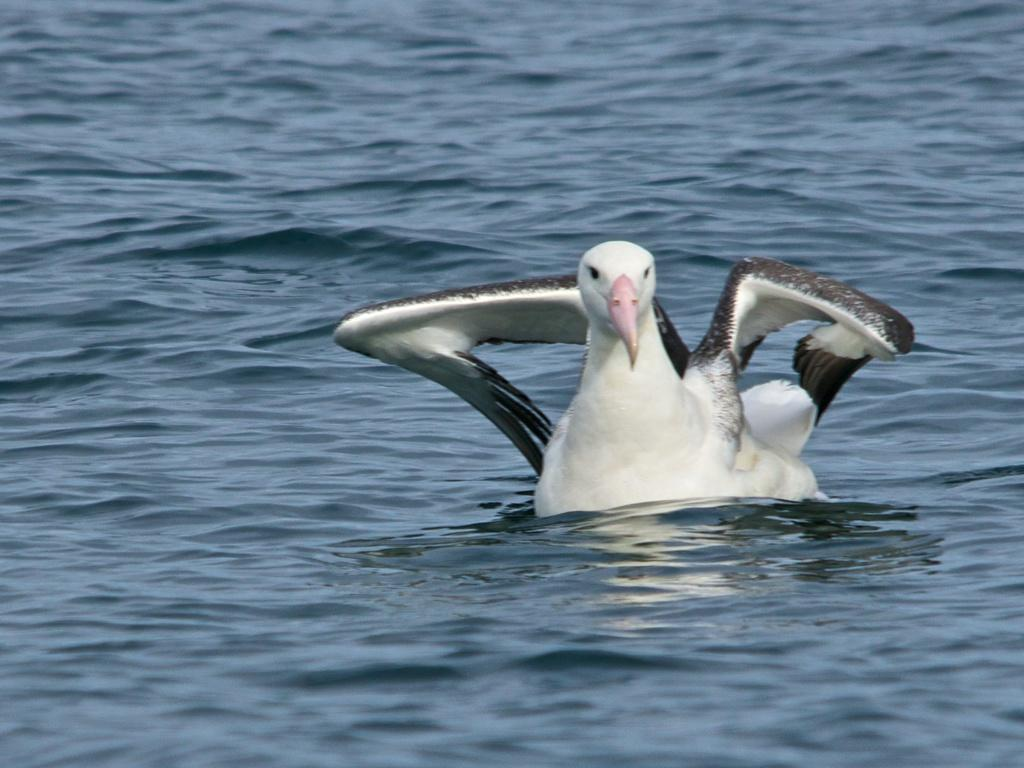What type of animal is in the image? There is an albatross in the image. Where is the albatross located? The albatross is in the water. What type of stocking is the albatross wearing in the image? There is no stocking present on the albatross in the image. Is the albatross a character from a fictional story in the image? The albatross is a real animal, not a fictional character, in the image. 